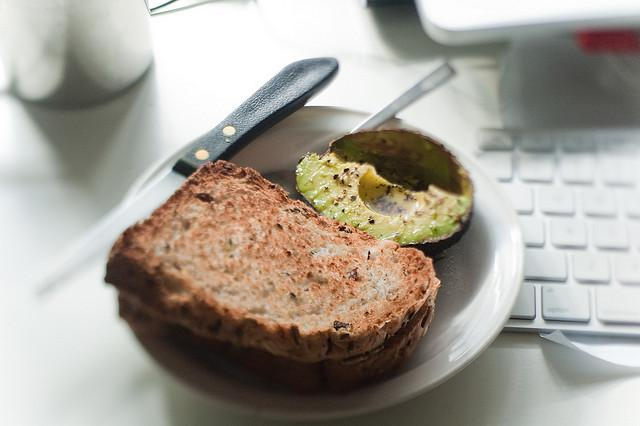What is going on the toast?

Choices:
A) butter
B) cream cheese
C) ants
D) avocado avocado 